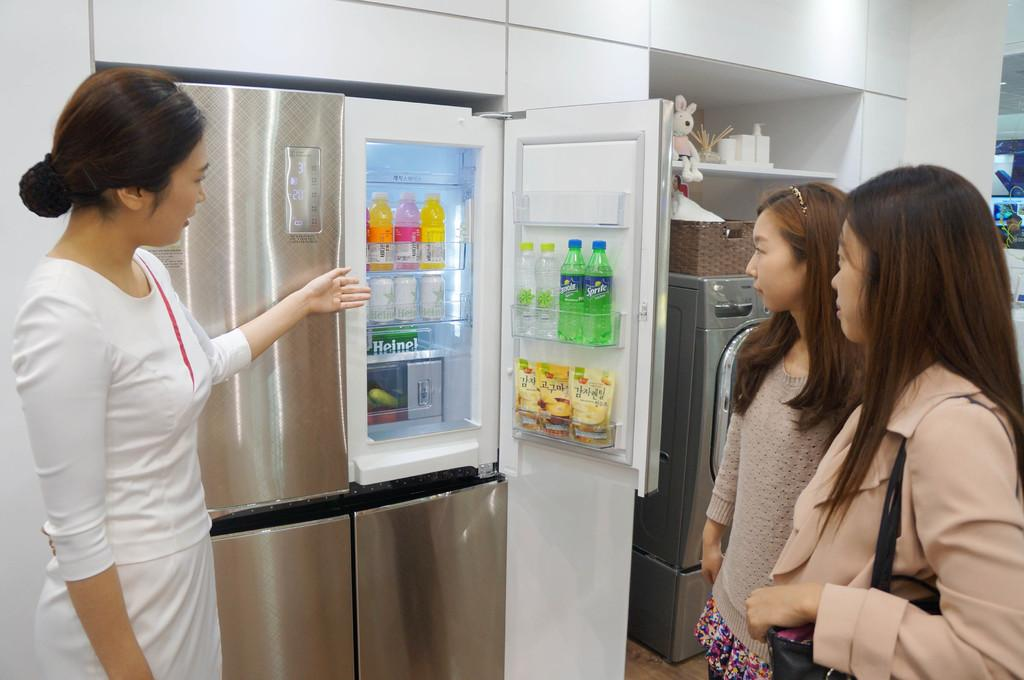<image>
Relay a brief, clear account of the picture shown. a seller showing a grey refrigerator,   with two sprite sodas on the door,  to two ladies 